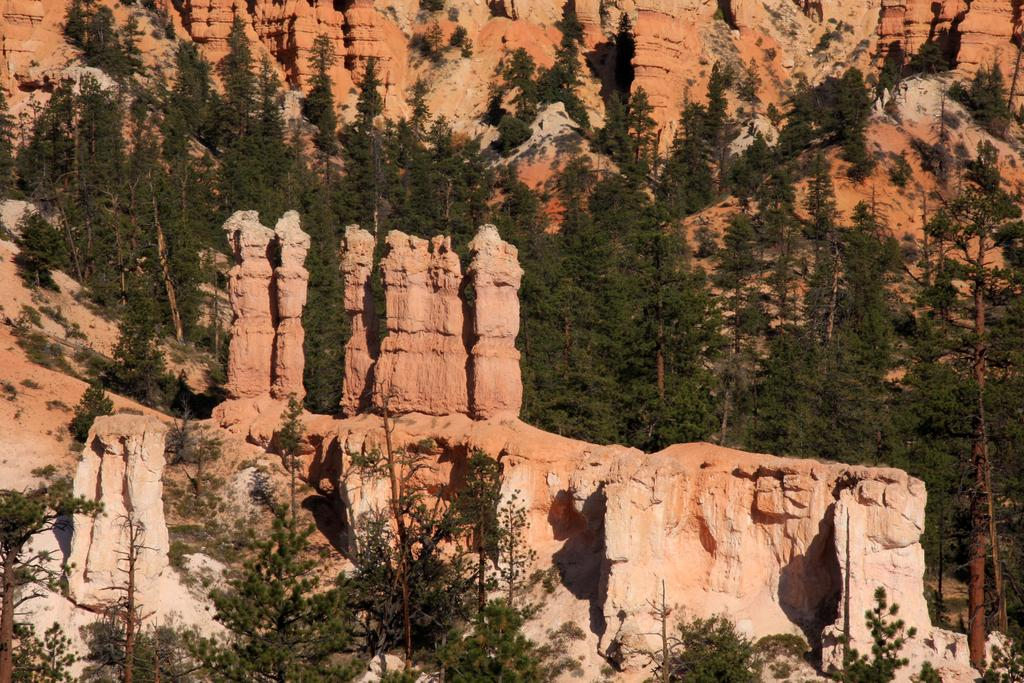What type of vegetation can be seen in the image? There are trees in the image. Where are the trees located? The trees are on a hill. How many deer can be seen coiled around the trees in the image? There are no deer present in the image, and the trees are not coiled around anything. 